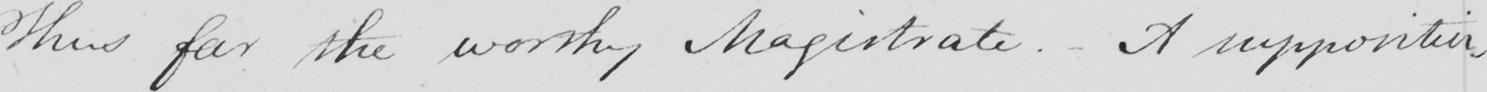What is written in this line of handwriting? Thus far the worthy Magistrate . - A supposition , 